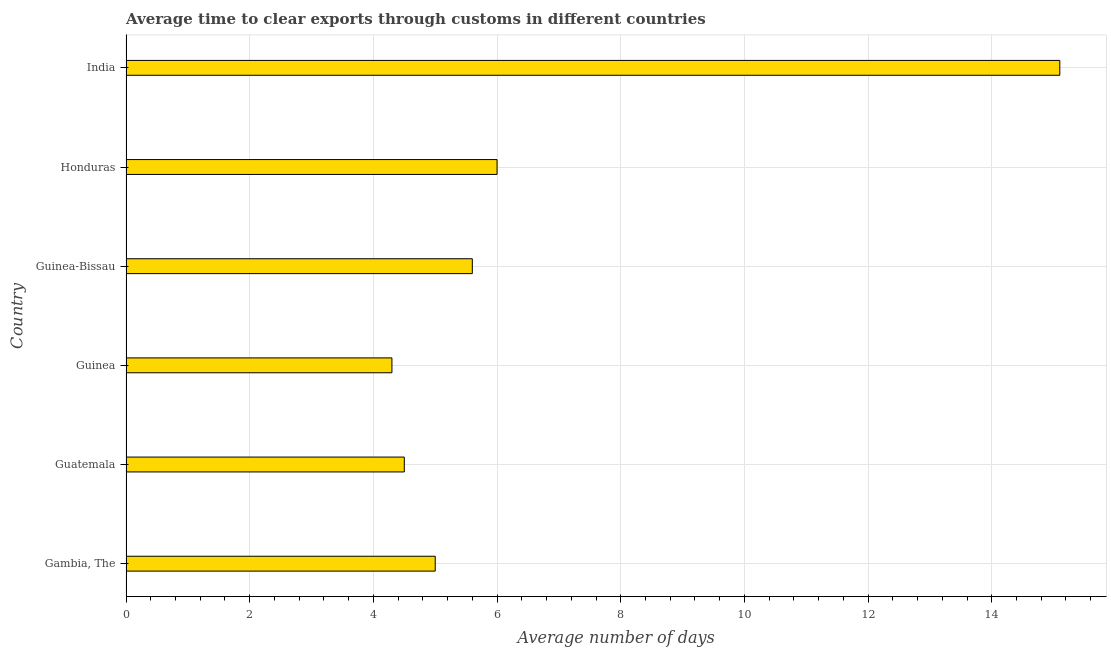Does the graph contain any zero values?
Ensure brevity in your answer.  No. What is the title of the graph?
Provide a succinct answer. Average time to clear exports through customs in different countries. What is the label or title of the X-axis?
Your response must be concise. Average number of days. What is the label or title of the Y-axis?
Offer a terse response. Country. In which country was the time to clear exports through customs minimum?
Keep it short and to the point. Guinea. What is the sum of the time to clear exports through customs?
Give a very brief answer. 40.5. What is the difference between the time to clear exports through customs in Guinea and Guinea-Bissau?
Offer a terse response. -1.3. What is the average time to clear exports through customs per country?
Keep it short and to the point. 6.75. What is the median time to clear exports through customs?
Your answer should be compact. 5.3. In how many countries, is the time to clear exports through customs greater than 4 days?
Your answer should be very brief. 6. What is the ratio of the time to clear exports through customs in Guinea to that in India?
Provide a succinct answer. 0.28. What is the difference between the highest and the second highest time to clear exports through customs?
Keep it short and to the point. 9.1. Are all the bars in the graph horizontal?
Make the answer very short. Yes. How many countries are there in the graph?
Ensure brevity in your answer.  6. Are the values on the major ticks of X-axis written in scientific E-notation?
Your response must be concise. No. What is the Average number of days in Guinea-Bissau?
Provide a short and direct response. 5.6. What is the Average number of days of Honduras?
Keep it short and to the point. 6. What is the Average number of days of India?
Offer a very short reply. 15.1. What is the difference between the Average number of days in Gambia, The and Guinea?
Keep it short and to the point. 0.7. What is the difference between the Average number of days in Gambia, The and India?
Ensure brevity in your answer.  -10.1. What is the difference between the Average number of days in Guatemala and Guinea?
Your answer should be very brief. 0.2. What is the difference between the Average number of days in Guatemala and Guinea-Bissau?
Your answer should be very brief. -1.1. What is the difference between the Average number of days in Guinea and Honduras?
Provide a succinct answer. -1.7. What is the difference between the Average number of days in Guinea and India?
Your response must be concise. -10.8. What is the difference between the Average number of days in Guinea-Bissau and Honduras?
Keep it short and to the point. -0.4. What is the difference between the Average number of days in Guinea-Bissau and India?
Your answer should be very brief. -9.5. What is the difference between the Average number of days in Honduras and India?
Provide a succinct answer. -9.1. What is the ratio of the Average number of days in Gambia, The to that in Guatemala?
Your answer should be very brief. 1.11. What is the ratio of the Average number of days in Gambia, The to that in Guinea?
Give a very brief answer. 1.16. What is the ratio of the Average number of days in Gambia, The to that in Guinea-Bissau?
Provide a succinct answer. 0.89. What is the ratio of the Average number of days in Gambia, The to that in Honduras?
Make the answer very short. 0.83. What is the ratio of the Average number of days in Gambia, The to that in India?
Ensure brevity in your answer.  0.33. What is the ratio of the Average number of days in Guatemala to that in Guinea?
Offer a very short reply. 1.05. What is the ratio of the Average number of days in Guatemala to that in Guinea-Bissau?
Provide a short and direct response. 0.8. What is the ratio of the Average number of days in Guatemala to that in India?
Your answer should be very brief. 0.3. What is the ratio of the Average number of days in Guinea to that in Guinea-Bissau?
Give a very brief answer. 0.77. What is the ratio of the Average number of days in Guinea to that in Honduras?
Make the answer very short. 0.72. What is the ratio of the Average number of days in Guinea to that in India?
Provide a succinct answer. 0.28. What is the ratio of the Average number of days in Guinea-Bissau to that in Honduras?
Your response must be concise. 0.93. What is the ratio of the Average number of days in Guinea-Bissau to that in India?
Give a very brief answer. 0.37. What is the ratio of the Average number of days in Honduras to that in India?
Your response must be concise. 0.4. 